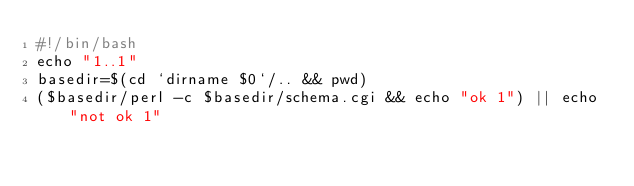Convert code to text. <code><loc_0><loc_0><loc_500><loc_500><_Perl_>#!/bin/bash
echo "1..1"
basedir=$(cd `dirname $0`/.. && pwd)
($basedir/perl -c $basedir/schema.cgi && echo "ok 1") || echo "not ok 1"
</code> 